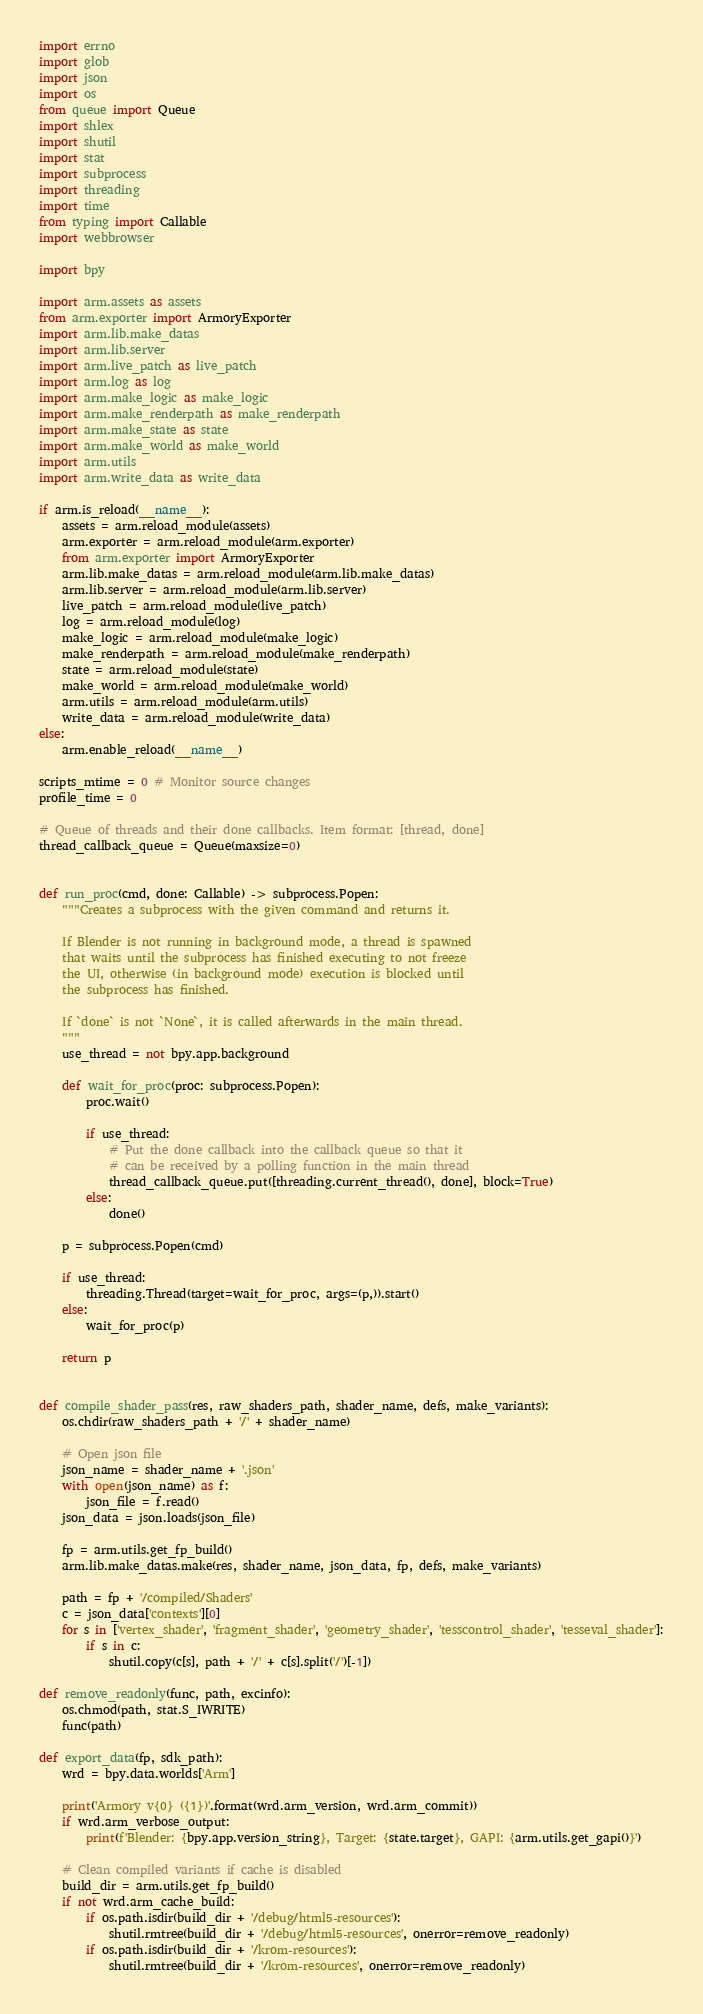<code> <loc_0><loc_0><loc_500><loc_500><_Python_>import errno
import glob
import json
import os
from queue import Queue
import shlex
import shutil
import stat
import subprocess
import threading
import time
from typing import Callable
import webbrowser

import bpy

import arm.assets as assets
from arm.exporter import ArmoryExporter
import arm.lib.make_datas
import arm.lib.server
import arm.live_patch as live_patch
import arm.log as log
import arm.make_logic as make_logic
import arm.make_renderpath as make_renderpath
import arm.make_state as state
import arm.make_world as make_world
import arm.utils
import arm.write_data as write_data

if arm.is_reload(__name__):
    assets = arm.reload_module(assets)
    arm.exporter = arm.reload_module(arm.exporter)
    from arm.exporter import ArmoryExporter
    arm.lib.make_datas = arm.reload_module(arm.lib.make_datas)
    arm.lib.server = arm.reload_module(arm.lib.server)
    live_patch = arm.reload_module(live_patch)
    log = arm.reload_module(log)
    make_logic = arm.reload_module(make_logic)
    make_renderpath = arm.reload_module(make_renderpath)
    state = arm.reload_module(state)
    make_world = arm.reload_module(make_world)
    arm.utils = arm.reload_module(arm.utils)
    write_data = arm.reload_module(write_data)
else:
    arm.enable_reload(__name__)

scripts_mtime = 0 # Monitor source changes
profile_time = 0

# Queue of threads and their done callbacks. Item format: [thread, done]
thread_callback_queue = Queue(maxsize=0)


def run_proc(cmd, done: Callable) -> subprocess.Popen:
    """Creates a subprocess with the given command and returns it.

    If Blender is not running in background mode, a thread is spawned
    that waits until the subprocess has finished executing to not freeze
    the UI, otherwise (in background mode) execution is blocked until
    the subprocess has finished.

    If `done` is not `None`, it is called afterwards in the main thread.
    """
    use_thread = not bpy.app.background

    def wait_for_proc(proc: subprocess.Popen):
        proc.wait()

        if use_thread:
            # Put the done callback into the callback queue so that it
            # can be received by a polling function in the main thread
            thread_callback_queue.put([threading.current_thread(), done], block=True)
        else:
            done()

    p = subprocess.Popen(cmd)

    if use_thread:
        threading.Thread(target=wait_for_proc, args=(p,)).start()
    else:
        wait_for_proc(p)

    return p


def compile_shader_pass(res, raw_shaders_path, shader_name, defs, make_variants):
    os.chdir(raw_shaders_path + '/' + shader_name)

    # Open json file
    json_name = shader_name + '.json'
    with open(json_name) as f:
        json_file = f.read()
    json_data = json.loads(json_file)

    fp = arm.utils.get_fp_build()
    arm.lib.make_datas.make(res, shader_name, json_data, fp, defs, make_variants)

    path = fp + '/compiled/Shaders'
    c = json_data['contexts'][0]
    for s in ['vertex_shader', 'fragment_shader', 'geometry_shader', 'tesscontrol_shader', 'tesseval_shader']:
        if s in c:
            shutil.copy(c[s], path + '/' + c[s].split('/')[-1])

def remove_readonly(func, path, excinfo):
    os.chmod(path, stat.S_IWRITE)
    func(path)

def export_data(fp, sdk_path):
    wrd = bpy.data.worlds['Arm']

    print('Armory v{0} ({1})'.format(wrd.arm_version, wrd.arm_commit))
    if wrd.arm_verbose_output:
        print(f'Blender: {bpy.app.version_string}, Target: {state.target}, GAPI: {arm.utils.get_gapi()}')

    # Clean compiled variants if cache is disabled
    build_dir = arm.utils.get_fp_build()
    if not wrd.arm_cache_build:
        if os.path.isdir(build_dir + '/debug/html5-resources'):
            shutil.rmtree(build_dir + '/debug/html5-resources', onerror=remove_readonly)
        if os.path.isdir(build_dir + '/krom-resources'):
            shutil.rmtree(build_dir + '/krom-resources', onerror=remove_readonly)</code> 